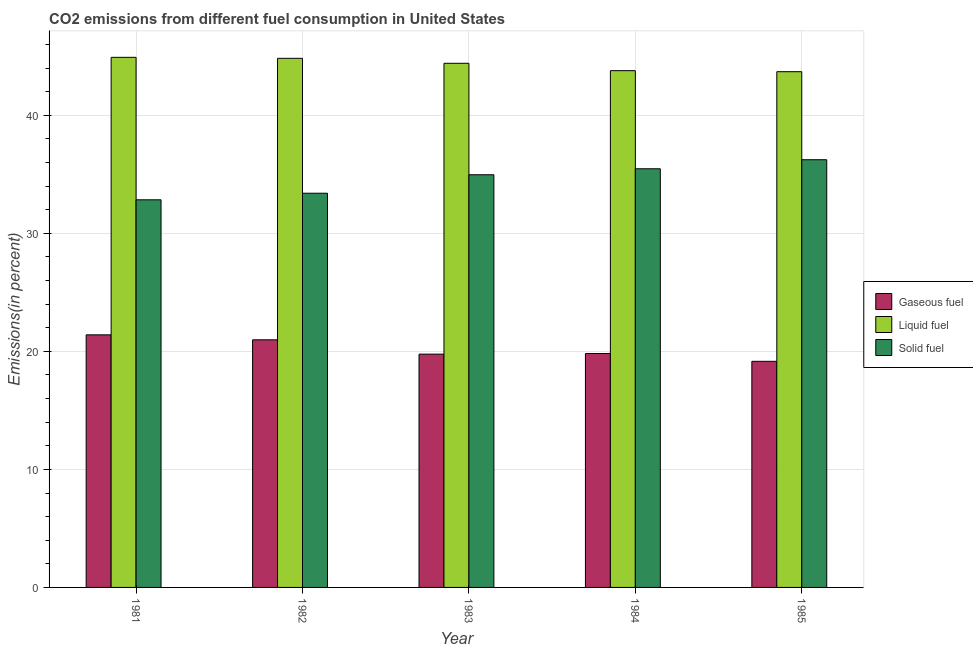How many different coloured bars are there?
Your response must be concise. 3. How many bars are there on the 4th tick from the left?
Provide a succinct answer. 3. What is the label of the 5th group of bars from the left?
Your answer should be compact. 1985. What is the percentage of solid fuel emission in 1983?
Provide a short and direct response. 34.96. Across all years, what is the maximum percentage of solid fuel emission?
Offer a terse response. 36.24. Across all years, what is the minimum percentage of gaseous fuel emission?
Make the answer very short. 19.16. In which year was the percentage of solid fuel emission minimum?
Offer a very short reply. 1981. What is the total percentage of liquid fuel emission in the graph?
Keep it short and to the point. 221.63. What is the difference between the percentage of liquid fuel emission in 1982 and that in 1985?
Provide a succinct answer. 1.13. What is the difference between the percentage of solid fuel emission in 1981 and the percentage of gaseous fuel emission in 1984?
Offer a very short reply. -2.63. What is the average percentage of gaseous fuel emission per year?
Offer a terse response. 20.22. In how many years, is the percentage of gaseous fuel emission greater than 22 %?
Ensure brevity in your answer.  0. What is the ratio of the percentage of gaseous fuel emission in 1982 to that in 1985?
Give a very brief answer. 1.1. Is the difference between the percentage of solid fuel emission in 1983 and 1985 greater than the difference between the percentage of gaseous fuel emission in 1983 and 1985?
Keep it short and to the point. No. What is the difference between the highest and the second highest percentage of solid fuel emission?
Give a very brief answer. 0.77. What is the difference between the highest and the lowest percentage of liquid fuel emission?
Keep it short and to the point. 1.22. In how many years, is the percentage of solid fuel emission greater than the average percentage of solid fuel emission taken over all years?
Offer a very short reply. 3. Is the sum of the percentage of gaseous fuel emission in 1981 and 1985 greater than the maximum percentage of liquid fuel emission across all years?
Your answer should be compact. Yes. What does the 1st bar from the left in 1983 represents?
Offer a terse response. Gaseous fuel. What does the 2nd bar from the right in 1983 represents?
Your response must be concise. Liquid fuel. Is it the case that in every year, the sum of the percentage of gaseous fuel emission and percentage of liquid fuel emission is greater than the percentage of solid fuel emission?
Provide a short and direct response. Yes. Are all the bars in the graph horizontal?
Ensure brevity in your answer.  No. Does the graph contain grids?
Give a very brief answer. Yes. Where does the legend appear in the graph?
Your answer should be very brief. Center right. What is the title of the graph?
Make the answer very short. CO2 emissions from different fuel consumption in United States. Does "Primary" appear as one of the legend labels in the graph?
Keep it short and to the point. No. What is the label or title of the X-axis?
Provide a short and direct response. Year. What is the label or title of the Y-axis?
Your answer should be compact. Emissions(in percent). What is the Emissions(in percent) of Gaseous fuel in 1981?
Make the answer very short. 21.4. What is the Emissions(in percent) of Liquid fuel in 1981?
Make the answer very short. 44.91. What is the Emissions(in percent) of Solid fuel in 1981?
Your answer should be compact. 32.84. What is the Emissions(in percent) in Gaseous fuel in 1982?
Your response must be concise. 20.98. What is the Emissions(in percent) of Liquid fuel in 1982?
Your answer should be compact. 44.83. What is the Emissions(in percent) in Solid fuel in 1982?
Your answer should be very brief. 33.4. What is the Emissions(in percent) in Gaseous fuel in 1983?
Your response must be concise. 19.77. What is the Emissions(in percent) of Liquid fuel in 1983?
Your response must be concise. 44.41. What is the Emissions(in percent) in Solid fuel in 1983?
Your response must be concise. 34.96. What is the Emissions(in percent) of Gaseous fuel in 1984?
Offer a very short reply. 19.82. What is the Emissions(in percent) in Liquid fuel in 1984?
Your response must be concise. 43.78. What is the Emissions(in percent) in Solid fuel in 1984?
Your answer should be compact. 35.47. What is the Emissions(in percent) in Gaseous fuel in 1985?
Your answer should be compact. 19.16. What is the Emissions(in percent) of Liquid fuel in 1985?
Give a very brief answer. 43.7. What is the Emissions(in percent) in Solid fuel in 1985?
Offer a very short reply. 36.24. Across all years, what is the maximum Emissions(in percent) of Gaseous fuel?
Offer a terse response. 21.4. Across all years, what is the maximum Emissions(in percent) of Liquid fuel?
Make the answer very short. 44.91. Across all years, what is the maximum Emissions(in percent) in Solid fuel?
Offer a very short reply. 36.24. Across all years, what is the minimum Emissions(in percent) of Gaseous fuel?
Offer a very short reply. 19.16. Across all years, what is the minimum Emissions(in percent) in Liquid fuel?
Provide a succinct answer. 43.7. Across all years, what is the minimum Emissions(in percent) of Solid fuel?
Offer a very short reply. 32.84. What is the total Emissions(in percent) in Gaseous fuel in the graph?
Your answer should be compact. 101.12. What is the total Emissions(in percent) in Liquid fuel in the graph?
Provide a succinct answer. 221.63. What is the total Emissions(in percent) in Solid fuel in the graph?
Your response must be concise. 172.91. What is the difference between the Emissions(in percent) of Gaseous fuel in 1981 and that in 1982?
Your response must be concise. 0.42. What is the difference between the Emissions(in percent) of Liquid fuel in 1981 and that in 1982?
Offer a very short reply. 0.08. What is the difference between the Emissions(in percent) of Solid fuel in 1981 and that in 1982?
Provide a succinct answer. -0.56. What is the difference between the Emissions(in percent) of Gaseous fuel in 1981 and that in 1983?
Give a very brief answer. 1.63. What is the difference between the Emissions(in percent) of Liquid fuel in 1981 and that in 1983?
Offer a terse response. 0.5. What is the difference between the Emissions(in percent) in Solid fuel in 1981 and that in 1983?
Provide a succinct answer. -2.12. What is the difference between the Emissions(in percent) of Gaseous fuel in 1981 and that in 1984?
Your answer should be very brief. 1.58. What is the difference between the Emissions(in percent) of Liquid fuel in 1981 and that in 1984?
Your answer should be very brief. 1.13. What is the difference between the Emissions(in percent) in Solid fuel in 1981 and that in 1984?
Your answer should be compact. -2.63. What is the difference between the Emissions(in percent) in Gaseous fuel in 1981 and that in 1985?
Give a very brief answer. 2.24. What is the difference between the Emissions(in percent) in Liquid fuel in 1981 and that in 1985?
Ensure brevity in your answer.  1.22. What is the difference between the Emissions(in percent) in Solid fuel in 1981 and that in 1985?
Offer a terse response. -3.4. What is the difference between the Emissions(in percent) in Gaseous fuel in 1982 and that in 1983?
Your answer should be very brief. 1.21. What is the difference between the Emissions(in percent) of Liquid fuel in 1982 and that in 1983?
Provide a succinct answer. 0.42. What is the difference between the Emissions(in percent) of Solid fuel in 1982 and that in 1983?
Provide a short and direct response. -1.56. What is the difference between the Emissions(in percent) in Gaseous fuel in 1982 and that in 1984?
Your answer should be very brief. 1.16. What is the difference between the Emissions(in percent) of Liquid fuel in 1982 and that in 1984?
Offer a terse response. 1.05. What is the difference between the Emissions(in percent) of Solid fuel in 1982 and that in 1984?
Provide a succinct answer. -2.07. What is the difference between the Emissions(in percent) of Gaseous fuel in 1982 and that in 1985?
Ensure brevity in your answer.  1.82. What is the difference between the Emissions(in percent) of Liquid fuel in 1982 and that in 1985?
Your response must be concise. 1.13. What is the difference between the Emissions(in percent) of Solid fuel in 1982 and that in 1985?
Give a very brief answer. -2.84. What is the difference between the Emissions(in percent) in Gaseous fuel in 1983 and that in 1984?
Provide a short and direct response. -0.05. What is the difference between the Emissions(in percent) of Liquid fuel in 1983 and that in 1984?
Provide a succinct answer. 0.62. What is the difference between the Emissions(in percent) in Solid fuel in 1983 and that in 1984?
Your answer should be compact. -0.51. What is the difference between the Emissions(in percent) of Gaseous fuel in 1983 and that in 1985?
Ensure brevity in your answer.  0.61. What is the difference between the Emissions(in percent) in Liquid fuel in 1983 and that in 1985?
Give a very brief answer. 0.71. What is the difference between the Emissions(in percent) of Solid fuel in 1983 and that in 1985?
Your response must be concise. -1.27. What is the difference between the Emissions(in percent) in Gaseous fuel in 1984 and that in 1985?
Make the answer very short. 0.66. What is the difference between the Emissions(in percent) in Liquid fuel in 1984 and that in 1985?
Offer a terse response. 0.09. What is the difference between the Emissions(in percent) in Solid fuel in 1984 and that in 1985?
Your answer should be very brief. -0.77. What is the difference between the Emissions(in percent) of Gaseous fuel in 1981 and the Emissions(in percent) of Liquid fuel in 1982?
Make the answer very short. -23.43. What is the difference between the Emissions(in percent) in Gaseous fuel in 1981 and the Emissions(in percent) in Solid fuel in 1982?
Provide a succinct answer. -12. What is the difference between the Emissions(in percent) of Liquid fuel in 1981 and the Emissions(in percent) of Solid fuel in 1982?
Provide a succinct answer. 11.51. What is the difference between the Emissions(in percent) in Gaseous fuel in 1981 and the Emissions(in percent) in Liquid fuel in 1983?
Your response must be concise. -23.01. What is the difference between the Emissions(in percent) in Gaseous fuel in 1981 and the Emissions(in percent) in Solid fuel in 1983?
Give a very brief answer. -13.56. What is the difference between the Emissions(in percent) in Liquid fuel in 1981 and the Emissions(in percent) in Solid fuel in 1983?
Ensure brevity in your answer.  9.95. What is the difference between the Emissions(in percent) in Gaseous fuel in 1981 and the Emissions(in percent) in Liquid fuel in 1984?
Your answer should be very brief. -22.38. What is the difference between the Emissions(in percent) of Gaseous fuel in 1981 and the Emissions(in percent) of Solid fuel in 1984?
Provide a short and direct response. -14.07. What is the difference between the Emissions(in percent) of Liquid fuel in 1981 and the Emissions(in percent) of Solid fuel in 1984?
Give a very brief answer. 9.44. What is the difference between the Emissions(in percent) of Gaseous fuel in 1981 and the Emissions(in percent) of Liquid fuel in 1985?
Keep it short and to the point. -22.3. What is the difference between the Emissions(in percent) in Gaseous fuel in 1981 and the Emissions(in percent) in Solid fuel in 1985?
Ensure brevity in your answer.  -14.84. What is the difference between the Emissions(in percent) in Liquid fuel in 1981 and the Emissions(in percent) in Solid fuel in 1985?
Keep it short and to the point. 8.68. What is the difference between the Emissions(in percent) of Gaseous fuel in 1982 and the Emissions(in percent) of Liquid fuel in 1983?
Provide a succinct answer. -23.43. What is the difference between the Emissions(in percent) in Gaseous fuel in 1982 and the Emissions(in percent) in Solid fuel in 1983?
Offer a very short reply. -13.99. What is the difference between the Emissions(in percent) in Liquid fuel in 1982 and the Emissions(in percent) in Solid fuel in 1983?
Your response must be concise. 9.87. What is the difference between the Emissions(in percent) in Gaseous fuel in 1982 and the Emissions(in percent) in Liquid fuel in 1984?
Your response must be concise. -22.81. What is the difference between the Emissions(in percent) of Gaseous fuel in 1982 and the Emissions(in percent) of Solid fuel in 1984?
Your response must be concise. -14.49. What is the difference between the Emissions(in percent) of Liquid fuel in 1982 and the Emissions(in percent) of Solid fuel in 1984?
Keep it short and to the point. 9.36. What is the difference between the Emissions(in percent) in Gaseous fuel in 1982 and the Emissions(in percent) in Liquid fuel in 1985?
Give a very brief answer. -22.72. What is the difference between the Emissions(in percent) in Gaseous fuel in 1982 and the Emissions(in percent) in Solid fuel in 1985?
Your answer should be compact. -15.26. What is the difference between the Emissions(in percent) in Liquid fuel in 1982 and the Emissions(in percent) in Solid fuel in 1985?
Offer a very short reply. 8.59. What is the difference between the Emissions(in percent) of Gaseous fuel in 1983 and the Emissions(in percent) of Liquid fuel in 1984?
Your answer should be compact. -24.02. What is the difference between the Emissions(in percent) in Gaseous fuel in 1983 and the Emissions(in percent) in Solid fuel in 1984?
Ensure brevity in your answer.  -15.7. What is the difference between the Emissions(in percent) of Liquid fuel in 1983 and the Emissions(in percent) of Solid fuel in 1984?
Offer a terse response. 8.94. What is the difference between the Emissions(in percent) in Gaseous fuel in 1983 and the Emissions(in percent) in Liquid fuel in 1985?
Keep it short and to the point. -23.93. What is the difference between the Emissions(in percent) of Gaseous fuel in 1983 and the Emissions(in percent) of Solid fuel in 1985?
Provide a short and direct response. -16.47. What is the difference between the Emissions(in percent) in Liquid fuel in 1983 and the Emissions(in percent) in Solid fuel in 1985?
Provide a succinct answer. 8.17. What is the difference between the Emissions(in percent) in Gaseous fuel in 1984 and the Emissions(in percent) in Liquid fuel in 1985?
Make the answer very short. -23.88. What is the difference between the Emissions(in percent) in Gaseous fuel in 1984 and the Emissions(in percent) in Solid fuel in 1985?
Make the answer very short. -16.42. What is the difference between the Emissions(in percent) of Liquid fuel in 1984 and the Emissions(in percent) of Solid fuel in 1985?
Make the answer very short. 7.55. What is the average Emissions(in percent) of Gaseous fuel per year?
Your answer should be compact. 20.22. What is the average Emissions(in percent) in Liquid fuel per year?
Ensure brevity in your answer.  44.33. What is the average Emissions(in percent) in Solid fuel per year?
Ensure brevity in your answer.  34.58. In the year 1981, what is the difference between the Emissions(in percent) in Gaseous fuel and Emissions(in percent) in Liquid fuel?
Your response must be concise. -23.51. In the year 1981, what is the difference between the Emissions(in percent) in Gaseous fuel and Emissions(in percent) in Solid fuel?
Keep it short and to the point. -11.44. In the year 1981, what is the difference between the Emissions(in percent) of Liquid fuel and Emissions(in percent) of Solid fuel?
Your answer should be very brief. 12.07. In the year 1982, what is the difference between the Emissions(in percent) of Gaseous fuel and Emissions(in percent) of Liquid fuel?
Offer a terse response. -23.85. In the year 1982, what is the difference between the Emissions(in percent) in Gaseous fuel and Emissions(in percent) in Solid fuel?
Provide a succinct answer. -12.42. In the year 1982, what is the difference between the Emissions(in percent) in Liquid fuel and Emissions(in percent) in Solid fuel?
Provide a succinct answer. 11.43. In the year 1983, what is the difference between the Emissions(in percent) of Gaseous fuel and Emissions(in percent) of Liquid fuel?
Your answer should be compact. -24.64. In the year 1983, what is the difference between the Emissions(in percent) of Gaseous fuel and Emissions(in percent) of Solid fuel?
Offer a very short reply. -15.2. In the year 1983, what is the difference between the Emissions(in percent) of Liquid fuel and Emissions(in percent) of Solid fuel?
Offer a very short reply. 9.45. In the year 1984, what is the difference between the Emissions(in percent) in Gaseous fuel and Emissions(in percent) in Liquid fuel?
Offer a terse response. -23.96. In the year 1984, what is the difference between the Emissions(in percent) of Gaseous fuel and Emissions(in percent) of Solid fuel?
Ensure brevity in your answer.  -15.65. In the year 1984, what is the difference between the Emissions(in percent) of Liquid fuel and Emissions(in percent) of Solid fuel?
Provide a short and direct response. 8.31. In the year 1985, what is the difference between the Emissions(in percent) of Gaseous fuel and Emissions(in percent) of Liquid fuel?
Offer a very short reply. -24.54. In the year 1985, what is the difference between the Emissions(in percent) in Gaseous fuel and Emissions(in percent) in Solid fuel?
Offer a terse response. -17.08. In the year 1985, what is the difference between the Emissions(in percent) of Liquid fuel and Emissions(in percent) of Solid fuel?
Make the answer very short. 7.46. What is the ratio of the Emissions(in percent) of Gaseous fuel in 1981 to that in 1982?
Provide a succinct answer. 1.02. What is the ratio of the Emissions(in percent) in Solid fuel in 1981 to that in 1982?
Your answer should be compact. 0.98. What is the ratio of the Emissions(in percent) of Gaseous fuel in 1981 to that in 1983?
Offer a terse response. 1.08. What is the ratio of the Emissions(in percent) of Liquid fuel in 1981 to that in 1983?
Your answer should be very brief. 1.01. What is the ratio of the Emissions(in percent) of Solid fuel in 1981 to that in 1983?
Your answer should be compact. 0.94. What is the ratio of the Emissions(in percent) of Gaseous fuel in 1981 to that in 1984?
Offer a terse response. 1.08. What is the ratio of the Emissions(in percent) in Liquid fuel in 1981 to that in 1984?
Offer a terse response. 1.03. What is the ratio of the Emissions(in percent) of Solid fuel in 1981 to that in 1984?
Give a very brief answer. 0.93. What is the ratio of the Emissions(in percent) in Gaseous fuel in 1981 to that in 1985?
Provide a succinct answer. 1.12. What is the ratio of the Emissions(in percent) of Liquid fuel in 1981 to that in 1985?
Your response must be concise. 1.03. What is the ratio of the Emissions(in percent) of Solid fuel in 1981 to that in 1985?
Ensure brevity in your answer.  0.91. What is the ratio of the Emissions(in percent) in Gaseous fuel in 1982 to that in 1983?
Give a very brief answer. 1.06. What is the ratio of the Emissions(in percent) of Liquid fuel in 1982 to that in 1983?
Make the answer very short. 1.01. What is the ratio of the Emissions(in percent) in Solid fuel in 1982 to that in 1983?
Offer a terse response. 0.96. What is the ratio of the Emissions(in percent) in Gaseous fuel in 1982 to that in 1984?
Keep it short and to the point. 1.06. What is the ratio of the Emissions(in percent) of Liquid fuel in 1982 to that in 1984?
Provide a succinct answer. 1.02. What is the ratio of the Emissions(in percent) of Solid fuel in 1982 to that in 1984?
Your answer should be very brief. 0.94. What is the ratio of the Emissions(in percent) of Gaseous fuel in 1982 to that in 1985?
Make the answer very short. 1.09. What is the ratio of the Emissions(in percent) in Liquid fuel in 1982 to that in 1985?
Provide a short and direct response. 1.03. What is the ratio of the Emissions(in percent) of Solid fuel in 1982 to that in 1985?
Make the answer very short. 0.92. What is the ratio of the Emissions(in percent) in Gaseous fuel in 1983 to that in 1984?
Provide a short and direct response. 1. What is the ratio of the Emissions(in percent) in Liquid fuel in 1983 to that in 1984?
Offer a terse response. 1.01. What is the ratio of the Emissions(in percent) in Solid fuel in 1983 to that in 1984?
Ensure brevity in your answer.  0.99. What is the ratio of the Emissions(in percent) in Gaseous fuel in 1983 to that in 1985?
Your response must be concise. 1.03. What is the ratio of the Emissions(in percent) of Liquid fuel in 1983 to that in 1985?
Offer a terse response. 1.02. What is the ratio of the Emissions(in percent) in Solid fuel in 1983 to that in 1985?
Offer a very short reply. 0.96. What is the ratio of the Emissions(in percent) in Gaseous fuel in 1984 to that in 1985?
Offer a very short reply. 1.03. What is the ratio of the Emissions(in percent) of Solid fuel in 1984 to that in 1985?
Offer a very short reply. 0.98. What is the difference between the highest and the second highest Emissions(in percent) in Gaseous fuel?
Give a very brief answer. 0.42. What is the difference between the highest and the second highest Emissions(in percent) in Liquid fuel?
Offer a terse response. 0.08. What is the difference between the highest and the second highest Emissions(in percent) in Solid fuel?
Keep it short and to the point. 0.77. What is the difference between the highest and the lowest Emissions(in percent) of Gaseous fuel?
Offer a very short reply. 2.24. What is the difference between the highest and the lowest Emissions(in percent) in Liquid fuel?
Make the answer very short. 1.22. What is the difference between the highest and the lowest Emissions(in percent) of Solid fuel?
Provide a short and direct response. 3.4. 